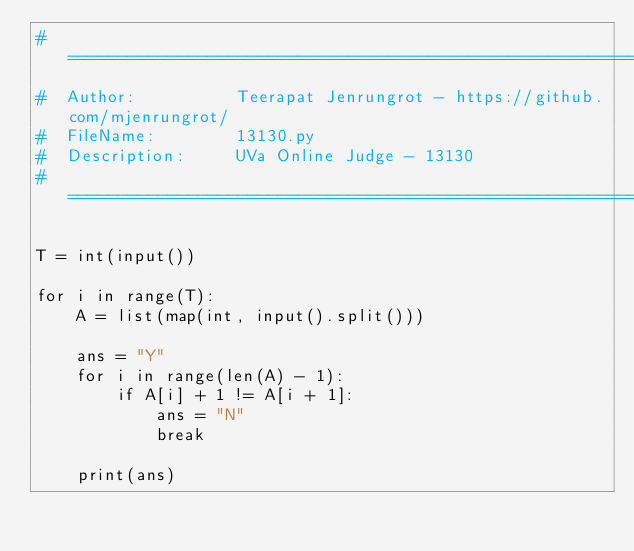Convert code to text. <code><loc_0><loc_0><loc_500><loc_500><_Python_># =============================================================================
#  Author:          Teerapat Jenrungrot - https://github.com/mjenrungrot/
#  FileName:        13130.py
#  Description:     UVa Online Judge - 13130
# =============================================================================

T = int(input())

for i in range(T):
    A = list(map(int, input().split()))

    ans = "Y"
    for i in range(len(A) - 1):
        if A[i] + 1 != A[i + 1]:
            ans = "N"
            break

    print(ans)
</code> 